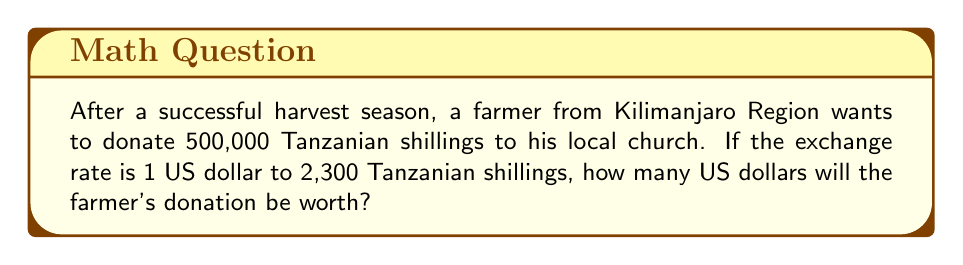Solve this math problem. To solve this problem, we need to convert Tanzanian shillings (TZS) to US dollars (USD). We'll use the given exchange rate and set up a proportion.

Step 1: Set up the proportion
$$\frac{1 \text{ USD}}{2300 \text{ TZS}} = \frac{x \text{ USD}}{500000 \text{ TZS}}$$

Step 2: Cross multiply
$$(1)(500000) = (2300)(x)$$

Step 3: Solve for x
$$500000 = 2300x$$
$$x = \frac{500000}{2300}$$

Step 4: Calculate the result
$$x = 217.3913043478261$$

Step 5: Round to two decimal places (standard for currency)
$$x \approx 217.39 \text{ USD}$$

Therefore, the farmer's donation of 500,000 Tanzanian shillings is equivalent to approximately $217.39 US dollars.
Answer: $217.39 